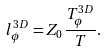<formula> <loc_0><loc_0><loc_500><loc_500>l _ { \phi } ^ { 3 D } = Z _ { 0 } \frac { T _ { \phi } ^ { 3 D } } { T } .</formula> 